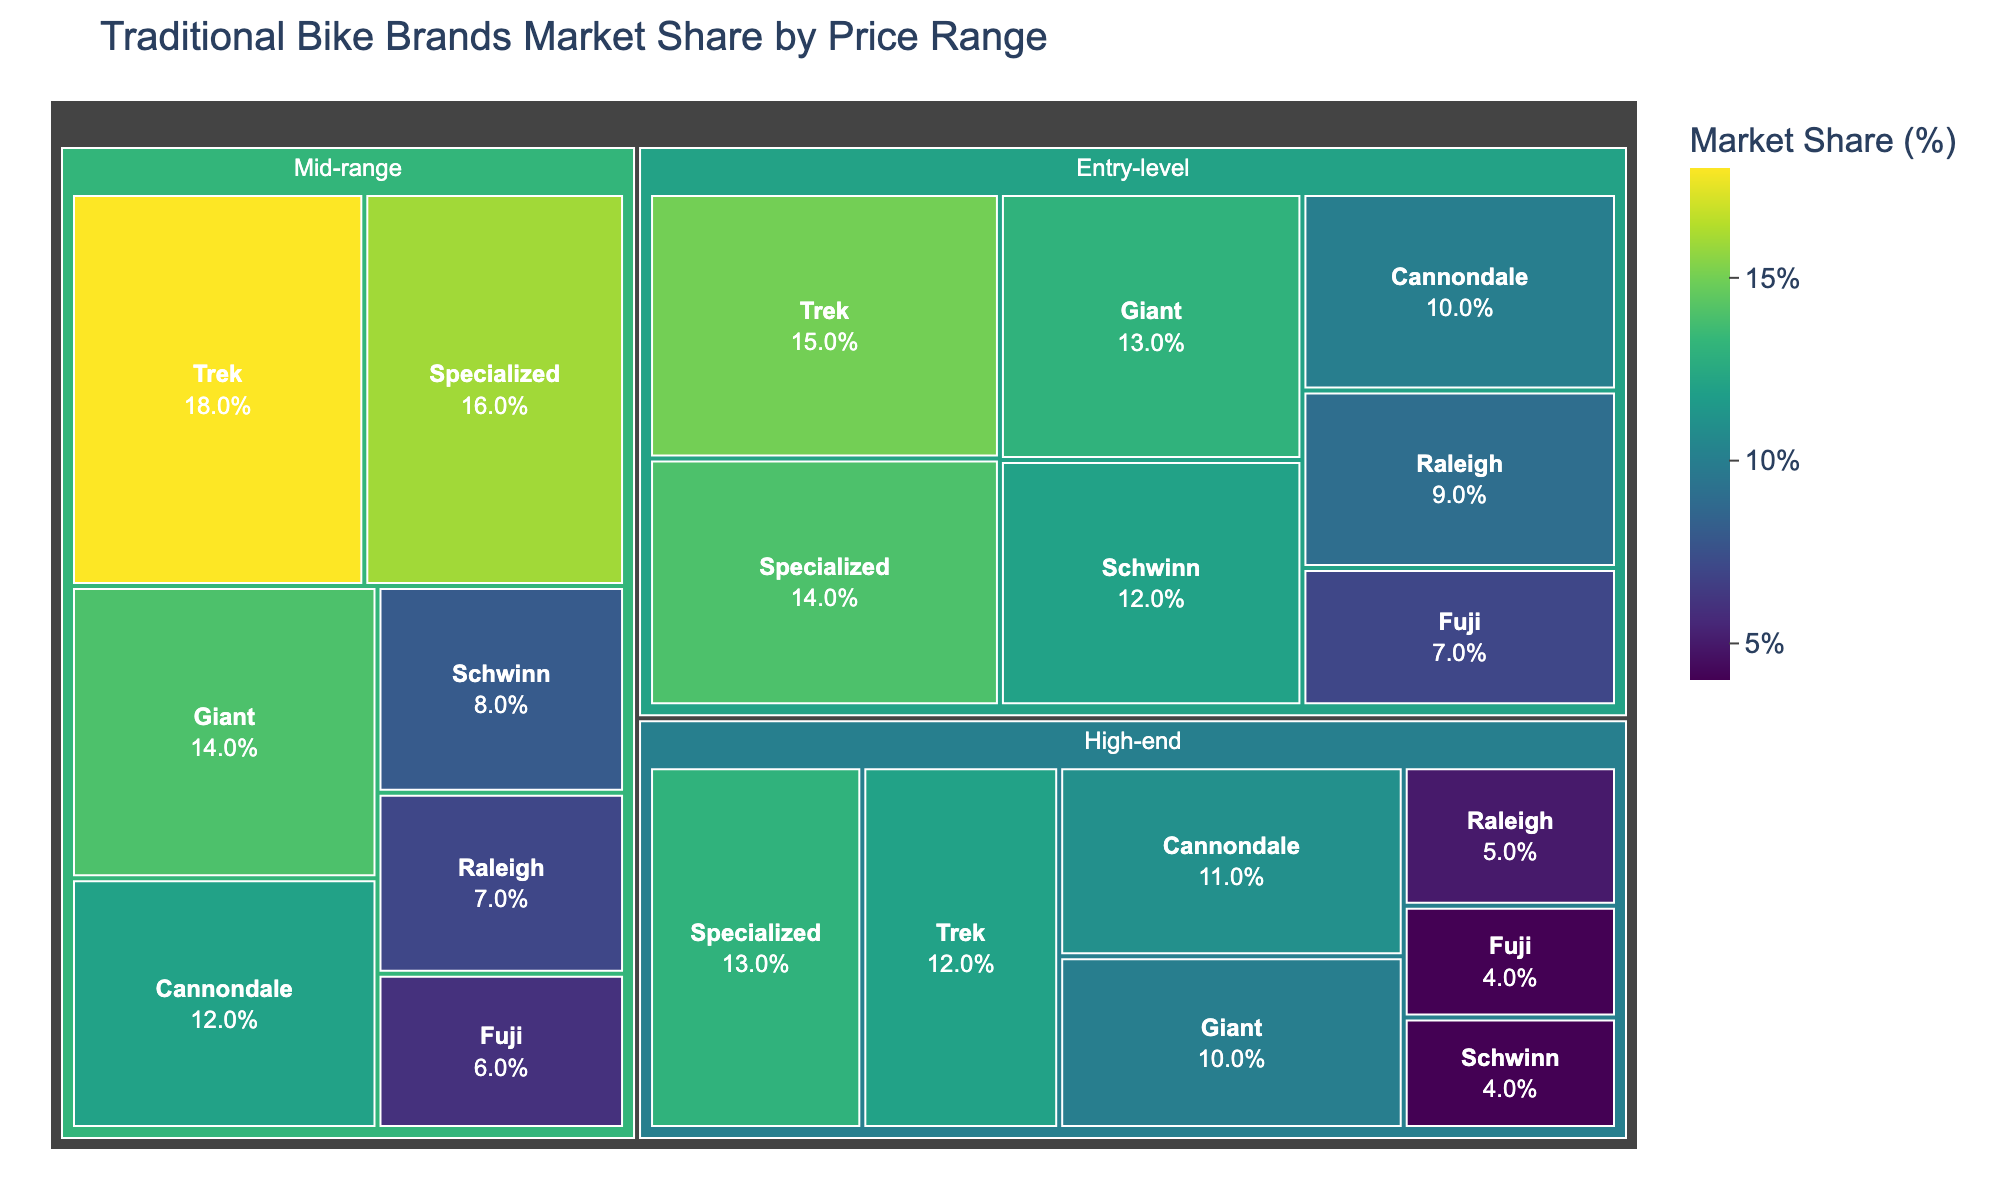What's the title of the figure? The title is typically placed at the top of the chart. In this case, it states "Traditional Bike Brands Market Share by Price Range" as specified in the code.
Answer: Traditional Bike Brands Market Share by Price Range Which brand has the highest market share in the Entry-level price range? To find this, look at the Entry-level section and identify which brand has the largest area. Trek has the largest area, indicating a 15% market share, which is the highest.
Answer: Trek What is the combined market share of all brands in the High-end price range? Sum up the market share values for all brands in the High-end category: 12 (Trek) + 13 (Specialized) + 10 (Giant) + 11 (Cannondale) + 4 (Schwinn) + 5 (Raleigh) + 4 (Fuji) = 59%.
Answer: 59% How does Specialized's market share in the Mid-range price range compare to Giant's market share in the same range? Compare Specialized's 16% market share in Mid-range with Giant's 14% market share in Mid-range. Specialized's share is higher.
Answer: Specialized has a higher market share Which price range has the highest total market share for Trek? Check Trek's market shares across all price ranges: 15% (Entry-level), 18% (Mid-range), 12% (High-end). Mid-range has the highest market share for Trek with 18%.
Answer: Mid-range How do the market shares of Schwinn and Raleigh in the Entry-level range compare? Compare Schwinn's 12% market share in Entry-level with Raleigh's 9% market share in the same range. Schwinn has a higher market share.
Answer: Schwinn has a higher market share What is the average market share for Giant across all price ranges? Calculate the average of Giant's market shares across Entry-level, Mid-range, and High-end: (13 + 14 + 10) / 3 = 12.33%.
Answer: 12.33% In which price range does Fuji have the smallest market share? Compare Fuji's market share across all price ranges: 7% (Entry-level), 6% (Mid-range), 4% (High-end). The smallest is in the High-end range with 4%.
Answer: High-end What is the difference between the market shares of Specialized and Cannondale in the High-end price range? Subtract Cannondale's 11% from Specialized's 13% in High-end: 13 - 11 = 2%.
Answer: 2% Which brand has the lowest market share in any price range? Identify the smallest market share among all brands in each price range: Trek (15, 18, 12), Specialized (14, 16, 13), Giant (13, 14, 10), Cannondale (10, 12, 11), Schwinn (12, 8, 4), Raleigh (9, 7, 5), Fuji (7, 6, 4). Schwinn and Fuji both have the lowest market share of 4% in High-end.
Answer: Schwinn and Fuji 